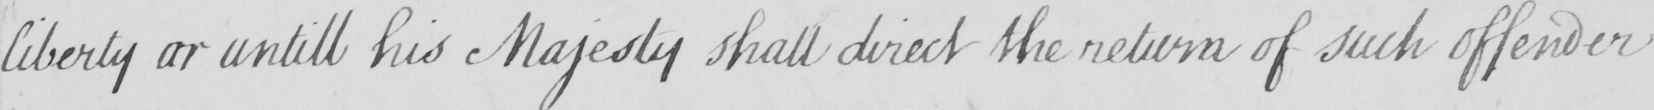What is written in this line of handwriting? liberty or untill his Majesty shall direct the return of such offender 